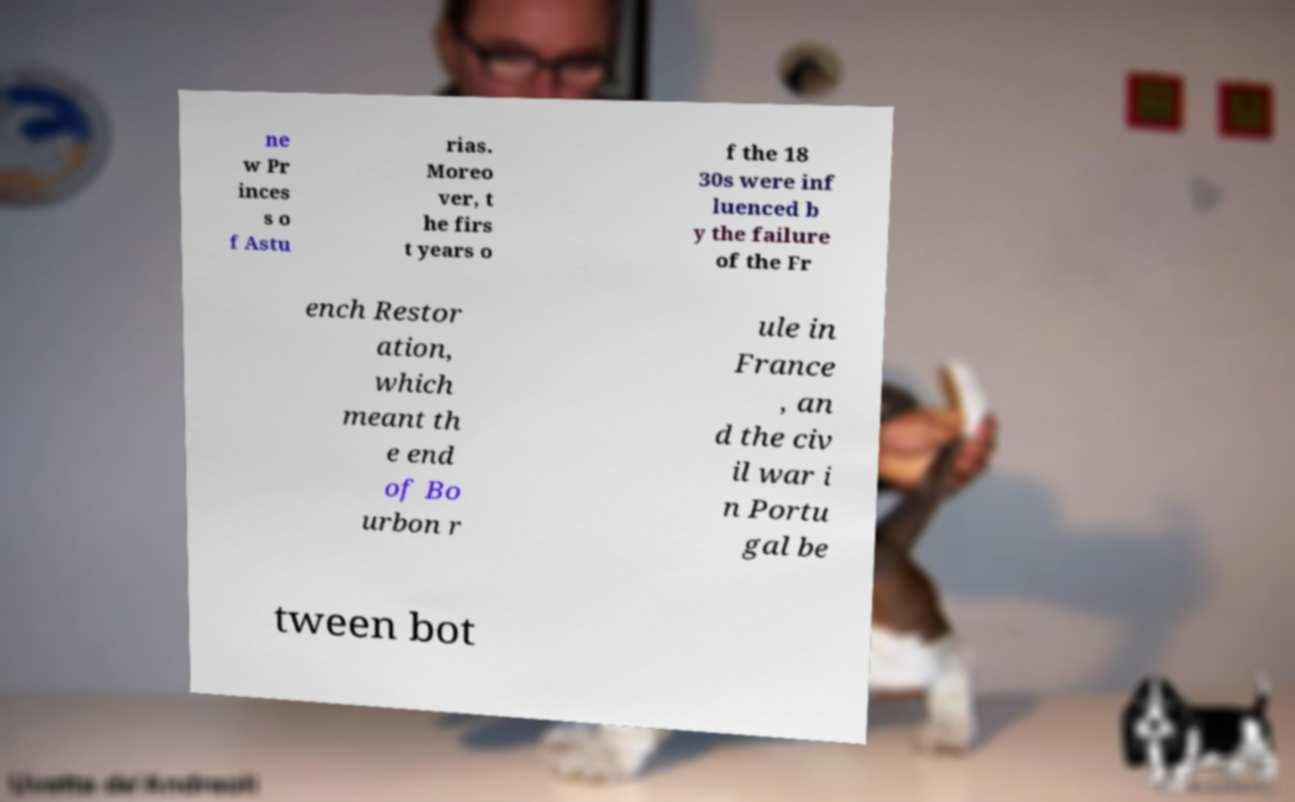For documentation purposes, I need the text within this image transcribed. Could you provide that? ne w Pr inces s o f Astu rias. Moreo ver, t he firs t years o f the 18 30s were inf luenced b y the failure of the Fr ench Restor ation, which meant th e end of Bo urbon r ule in France , an d the civ il war i n Portu gal be tween bot 